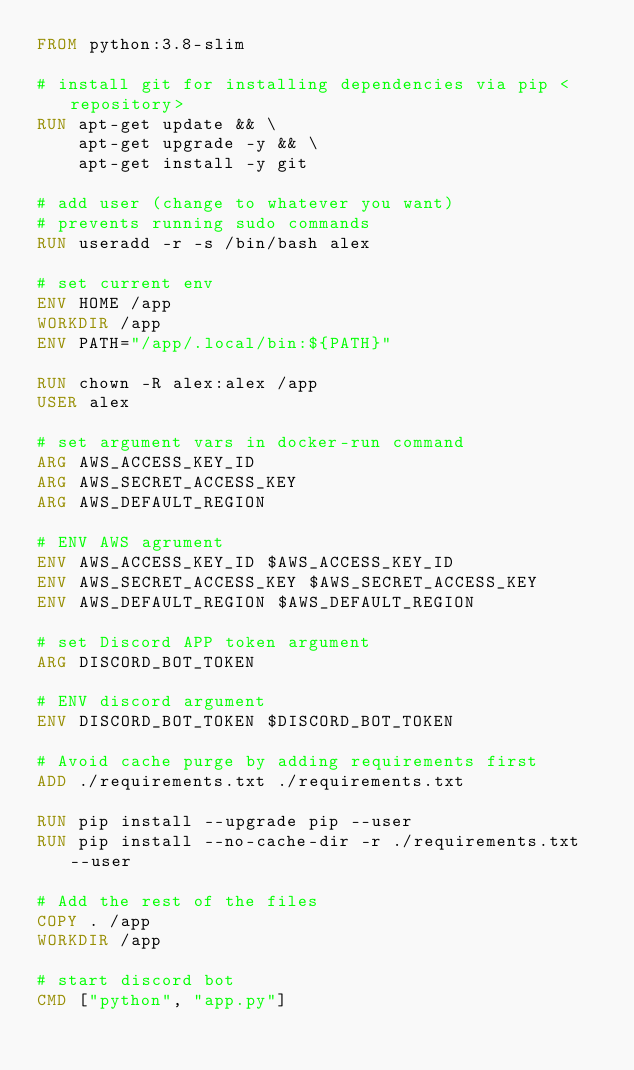<code> <loc_0><loc_0><loc_500><loc_500><_Dockerfile_>FROM python:3.8-slim

# install git for installing dependencies via pip <repository>
RUN apt-get update && \
    apt-get upgrade -y && \
    apt-get install -y git

# add user (change to whatever you want)
# prevents running sudo commands
RUN useradd -r -s /bin/bash alex

# set current env
ENV HOME /app
WORKDIR /app
ENV PATH="/app/.local/bin:${PATH}"

RUN chown -R alex:alex /app
USER alex

# set argument vars in docker-run command
ARG AWS_ACCESS_KEY_ID
ARG AWS_SECRET_ACCESS_KEY
ARG AWS_DEFAULT_REGION

# ENV AWS agrument
ENV AWS_ACCESS_KEY_ID $AWS_ACCESS_KEY_ID
ENV AWS_SECRET_ACCESS_KEY $AWS_SECRET_ACCESS_KEY
ENV AWS_DEFAULT_REGION $AWS_DEFAULT_REGION

# set Discord APP token argument
ARG DISCORD_BOT_TOKEN

# ENV discord argument
ENV DISCORD_BOT_TOKEN $DISCORD_BOT_TOKEN

# Avoid cache purge by adding requirements first
ADD ./requirements.txt ./requirements.txt

RUN pip install --upgrade pip --user
RUN pip install --no-cache-dir -r ./requirements.txt --user

# Add the rest of the files
COPY . /app
WORKDIR /app

# start discord bot
CMD ["python", "app.py"]
</code> 